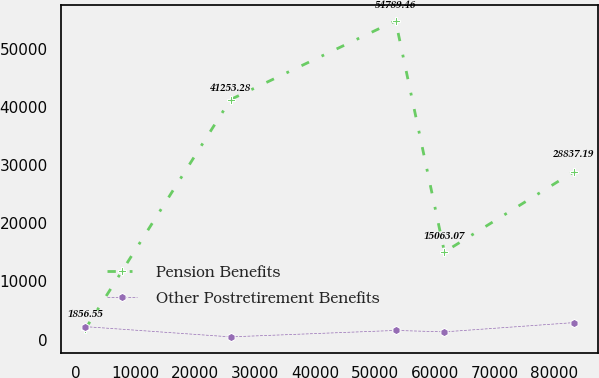<chart> <loc_0><loc_0><loc_500><loc_500><line_chart><ecel><fcel>Pension Benefits<fcel>Other Postretirement Benefits<nl><fcel>1655.81<fcel>1856.55<fcel>2233.68<nl><fcel>25903.4<fcel>41253.3<fcel>478.21<nl><fcel>53486.5<fcel>54789.5<fcel>1584.56<nl><fcel>61645.1<fcel>15063.1<fcel>1339.65<nl><fcel>83241.4<fcel>28837.2<fcel>2927.33<nl></chart> 